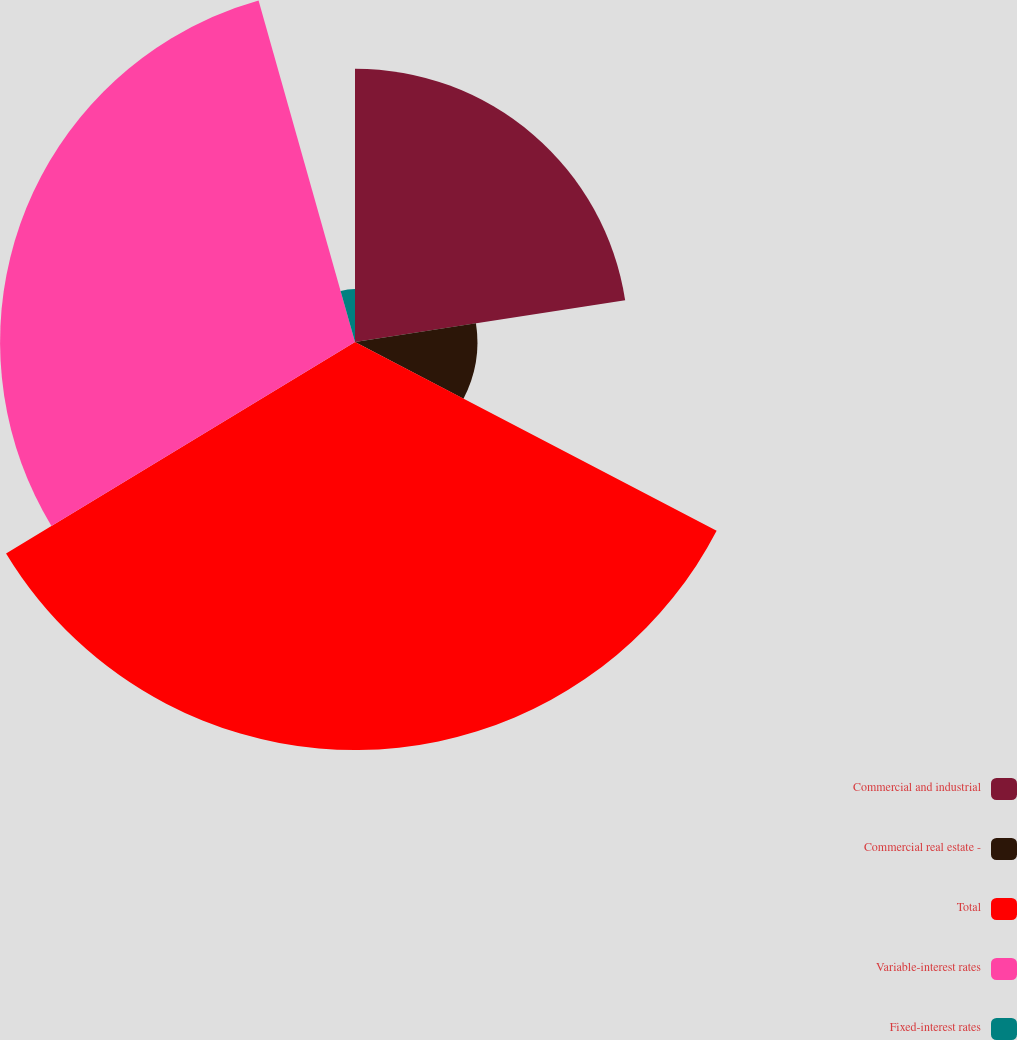Convert chart to OTSL. <chart><loc_0><loc_0><loc_500><loc_500><pie_chart><fcel>Commercial and industrial<fcel>Commercial real estate -<fcel>Total<fcel>Variable-interest rates<fcel>Fixed-interest rates<nl><fcel>22.56%<fcel>10.1%<fcel>33.67%<fcel>29.29%<fcel>4.38%<nl></chart> 